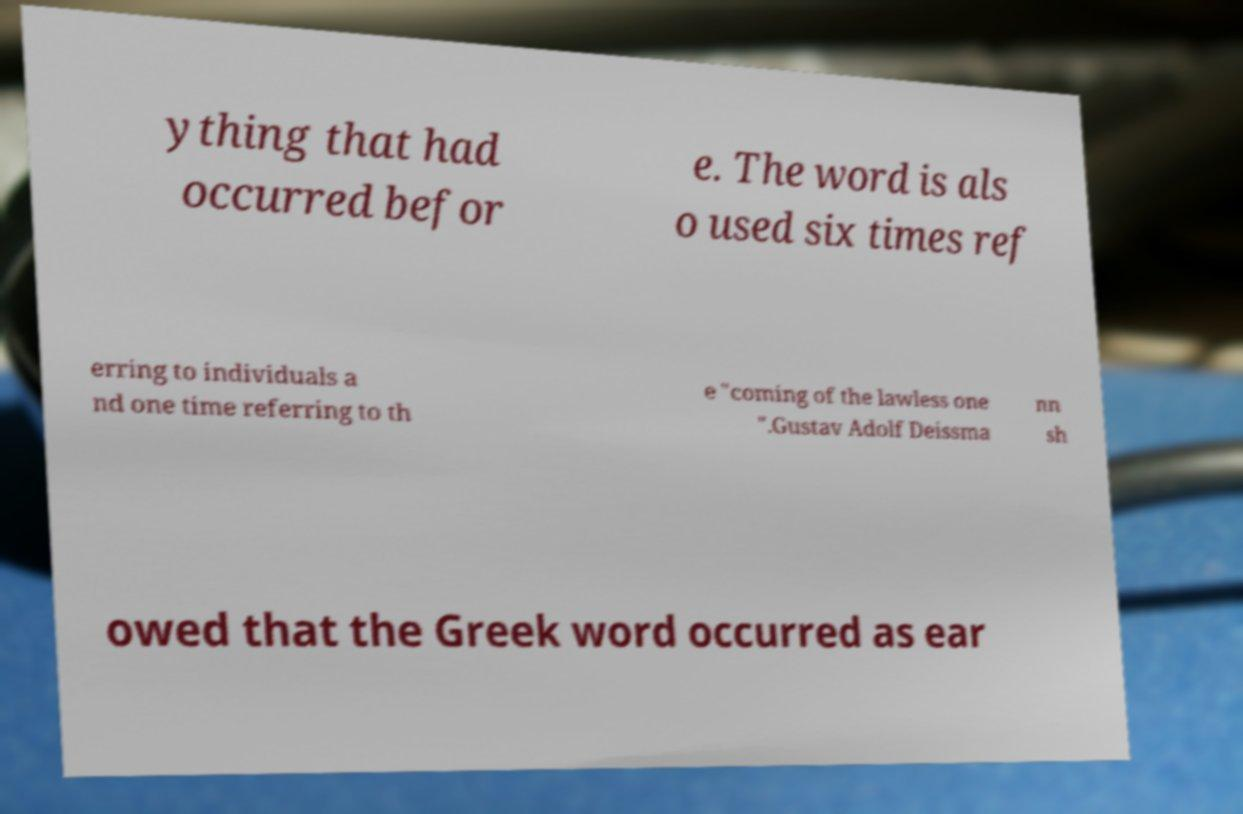Can you accurately transcribe the text from the provided image for me? ything that had occurred befor e. The word is als o used six times ref erring to individuals a nd one time referring to th e "coming of the lawless one ".Gustav Adolf Deissma nn sh owed that the Greek word occurred as ear 